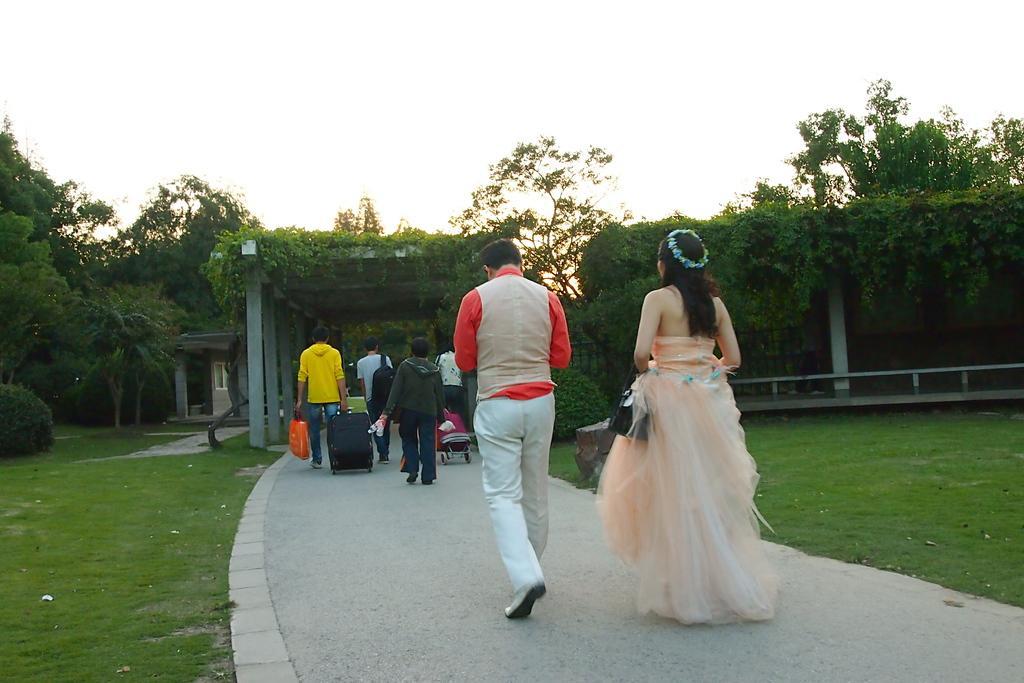Describe this image in one or two sentences. Here is the man and woman walking. I can see a group of people holding bags and pulling trolleys on the pathway. These are the pillars with creepers on it. I can see the trees. This is the grass. I can see a house with a window. 